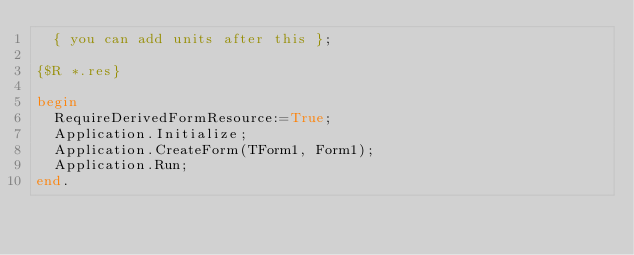Convert code to text. <code><loc_0><loc_0><loc_500><loc_500><_Pascal_>  { you can add units after this };

{$R *.res}

begin
  RequireDerivedFormResource:=True;
  Application.Initialize;
  Application.CreateForm(TForm1, Form1);
  Application.Run;
end.

</code> 